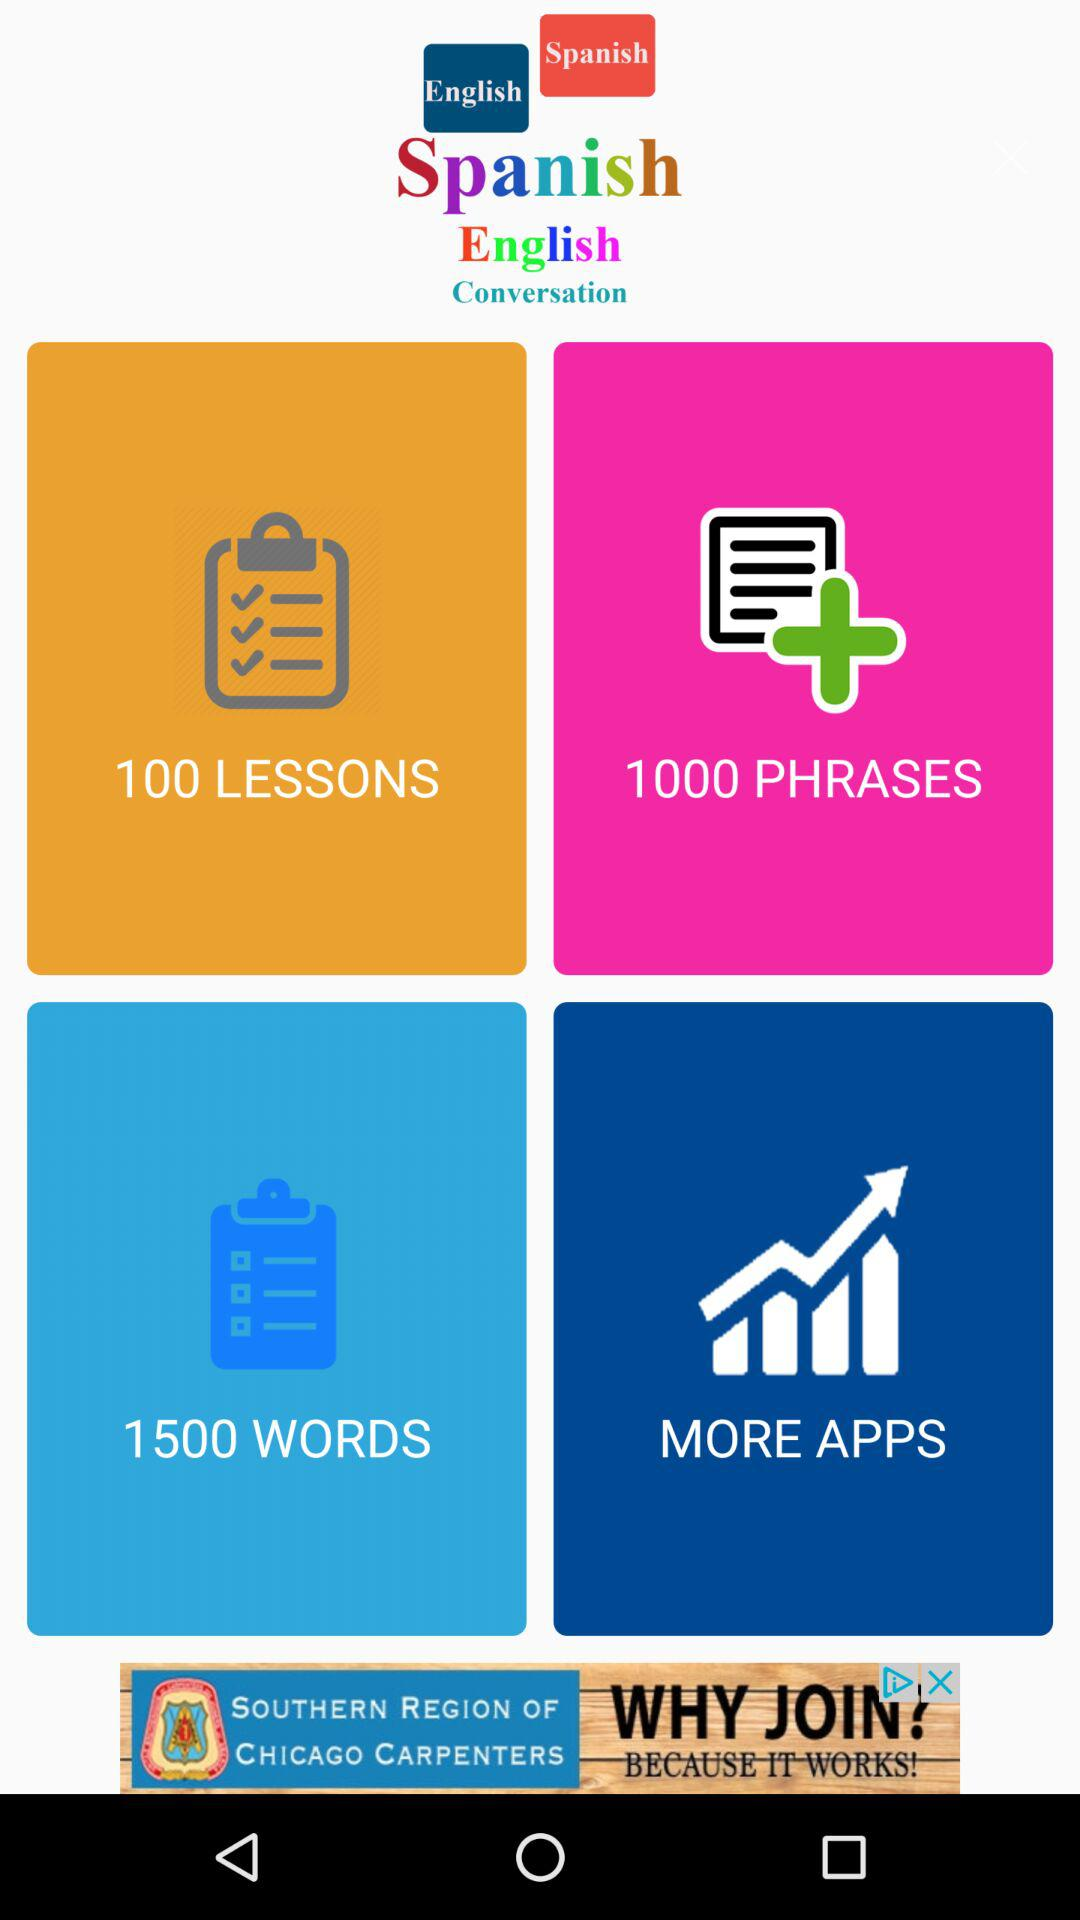How many words are there? There are 1500 words. 